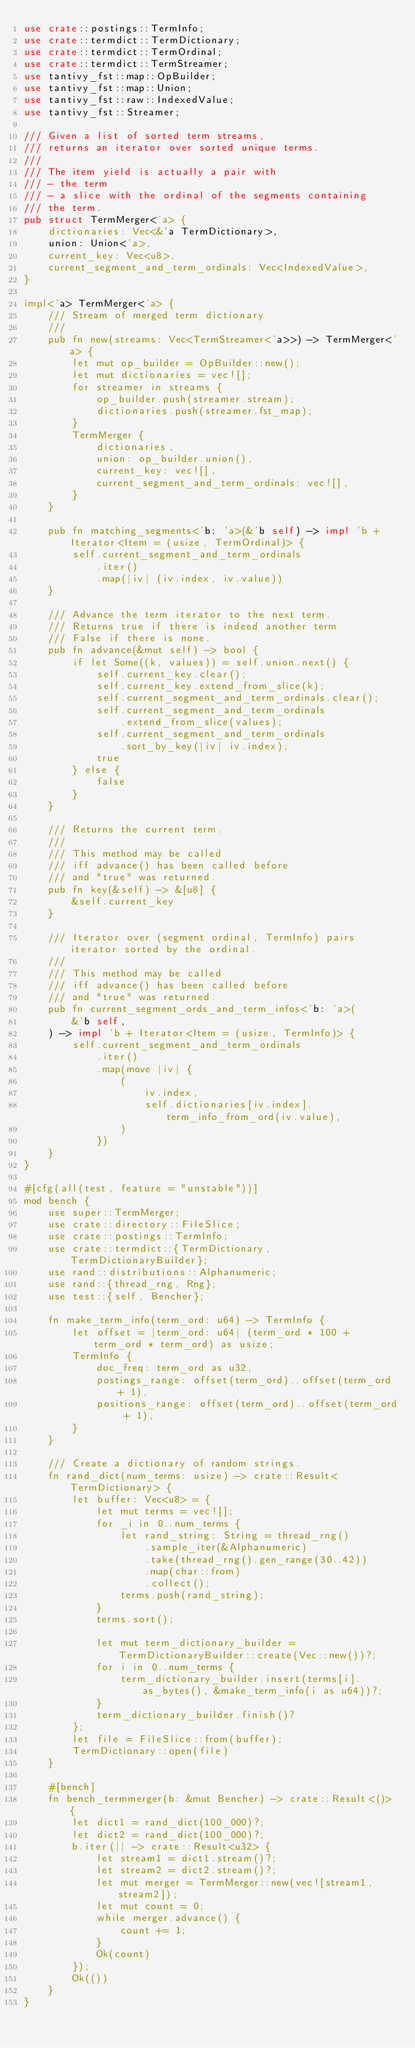Convert code to text. <code><loc_0><loc_0><loc_500><loc_500><_Rust_>use crate::postings::TermInfo;
use crate::termdict::TermDictionary;
use crate::termdict::TermOrdinal;
use crate::termdict::TermStreamer;
use tantivy_fst::map::OpBuilder;
use tantivy_fst::map::Union;
use tantivy_fst::raw::IndexedValue;
use tantivy_fst::Streamer;

/// Given a list of sorted term streams,
/// returns an iterator over sorted unique terms.
///
/// The item yield is actually a pair with
/// - the term
/// - a slice with the ordinal of the segments containing
/// the term.
pub struct TermMerger<'a> {
    dictionaries: Vec<&'a TermDictionary>,
    union: Union<'a>,
    current_key: Vec<u8>,
    current_segment_and_term_ordinals: Vec<IndexedValue>,
}

impl<'a> TermMerger<'a> {
    /// Stream of merged term dictionary
    ///
    pub fn new(streams: Vec<TermStreamer<'a>>) -> TermMerger<'a> {
        let mut op_builder = OpBuilder::new();
        let mut dictionaries = vec![];
        for streamer in streams {
            op_builder.push(streamer.stream);
            dictionaries.push(streamer.fst_map);
        }
        TermMerger {
            dictionaries,
            union: op_builder.union(),
            current_key: vec![],
            current_segment_and_term_ordinals: vec![],
        }
    }

    pub fn matching_segments<'b: 'a>(&'b self) -> impl 'b + Iterator<Item = (usize, TermOrdinal)> {
        self.current_segment_and_term_ordinals
            .iter()
            .map(|iv| (iv.index, iv.value))
    }

    /// Advance the term iterator to the next term.
    /// Returns true if there is indeed another term
    /// False if there is none.
    pub fn advance(&mut self) -> bool {
        if let Some((k, values)) = self.union.next() {
            self.current_key.clear();
            self.current_key.extend_from_slice(k);
            self.current_segment_and_term_ordinals.clear();
            self.current_segment_and_term_ordinals
                .extend_from_slice(values);
            self.current_segment_and_term_ordinals
                .sort_by_key(|iv| iv.index);
            true
        } else {
            false
        }
    }

    /// Returns the current term.
    ///
    /// This method may be called
    /// iff advance() has been called before
    /// and "true" was returned.
    pub fn key(&self) -> &[u8] {
        &self.current_key
    }

    /// Iterator over (segment ordinal, TermInfo) pairs iterator sorted by the ordinal.
    ///
    /// This method may be called
    /// iff advance() has been called before
    /// and "true" was returned.
    pub fn current_segment_ords_and_term_infos<'b: 'a>(
        &'b self,
    ) -> impl 'b + Iterator<Item = (usize, TermInfo)> {
        self.current_segment_and_term_ordinals
            .iter()
            .map(move |iv| {
                (
                    iv.index,
                    self.dictionaries[iv.index].term_info_from_ord(iv.value),
                )
            })
    }
}

#[cfg(all(test, feature = "unstable"))]
mod bench {
    use super::TermMerger;
    use crate::directory::FileSlice;
    use crate::postings::TermInfo;
    use crate::termdict::{TermDictionary, TermDictionaryBuilder};
    use rand::distributions::Alphanumeric;
    use rand::{thread_rng, Rng};
    use test::{self, Bencher};

    fn make_term_info(term_ord: u64) -> TermInfo {
        let offset = |term_ord: u64| (term_ord * 100 + term_ord * term_ord) as usize;
        TermInfo {
            doc_freq: term_ord as u32,
            postings_range: offset(term_ord)..offset(term_ord + 1),
            positions_range: offset(term_ord)..offset(term_ord + 1),
        }
    }

    /// Create a dictionary of random strings.
    fn rand_dict(num_terms: usize) -> crate::Result<TermDictionary> {
        let buffer: Vec<u8> = {
            let mut terms = vec![];
            for _i in 0..num_terms {
                let rand_string: String = thread_rng()
                    .sample_iter(&Alphanumeric)
                    .take(thread_rng().gen_range(30..42))
                    .map(char::from)
                    .collect();
                terms.push(rand_string);
            }
            terms.sort();

            let mut term_dictionary_builder = TermDictionaryBuilder::create(Vec::new())?;
            for i in 0..num_terms {
                term_dictionary_builder.insert(terms[i].as_bytes(), &make_term_info(i as u64))?;
            }
            term_dictionary_builder.finish()?
        };
        let file = FileSlice::from(buffer);
        TermDictionary::open(file)
    }

    #[bench]
    fn bench_termmerger(b: &mut Bencher) -> crate::Result<()> {
        let dict1 = rand_dict(100_000)?;
        let dict2 = rand_dict(100_000)?;
        b.iter(|| -> crate::Result<u32> {
            let stream1 = dict1.stream()?;
            let stream2 = dict2.stream()?;
            let mut merger = TermMerger::new(vec![stream1, stream2]);
            let mut count = 0;
            while merger.advance() {
                count += 1;
            }
            Ok(count)
        });
        Ok(())
    }
}
</code> 